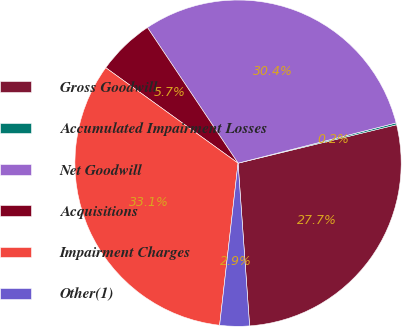Convert chart. <chart><loc_0><loc_0><loc_500><loc_500><pie_chart><fcel>Gross Goodwill<fcel>Accumulated Impairment Losses<fcel>Net Goodwill<fcel>Acquisitions<fcel>Impairment Charges<fcel>Other(1)<nl><fcel>27.66%<fcel>0.18%<fcel>30.41%<fcel>5.68%<fcel>33.15%<fcel>2.93%<nl></chart> 